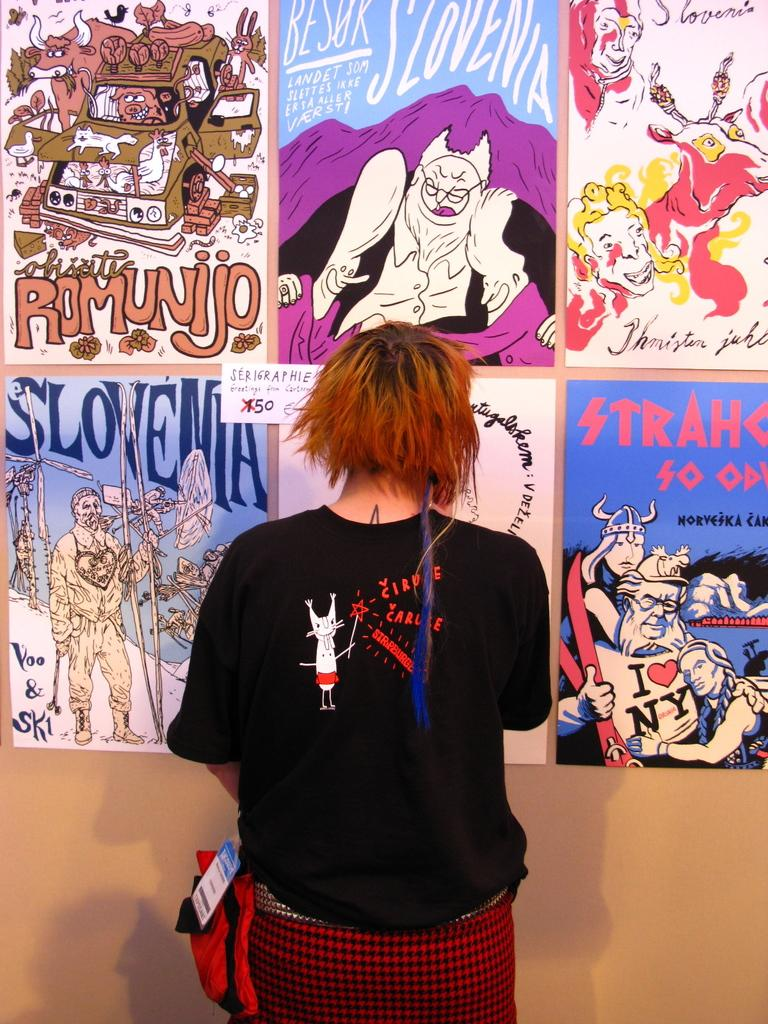<image>
Render a clear and concise summary of the photo. A woman with orange hair is standing in front of a wall with different posters including one for Slovenia. 